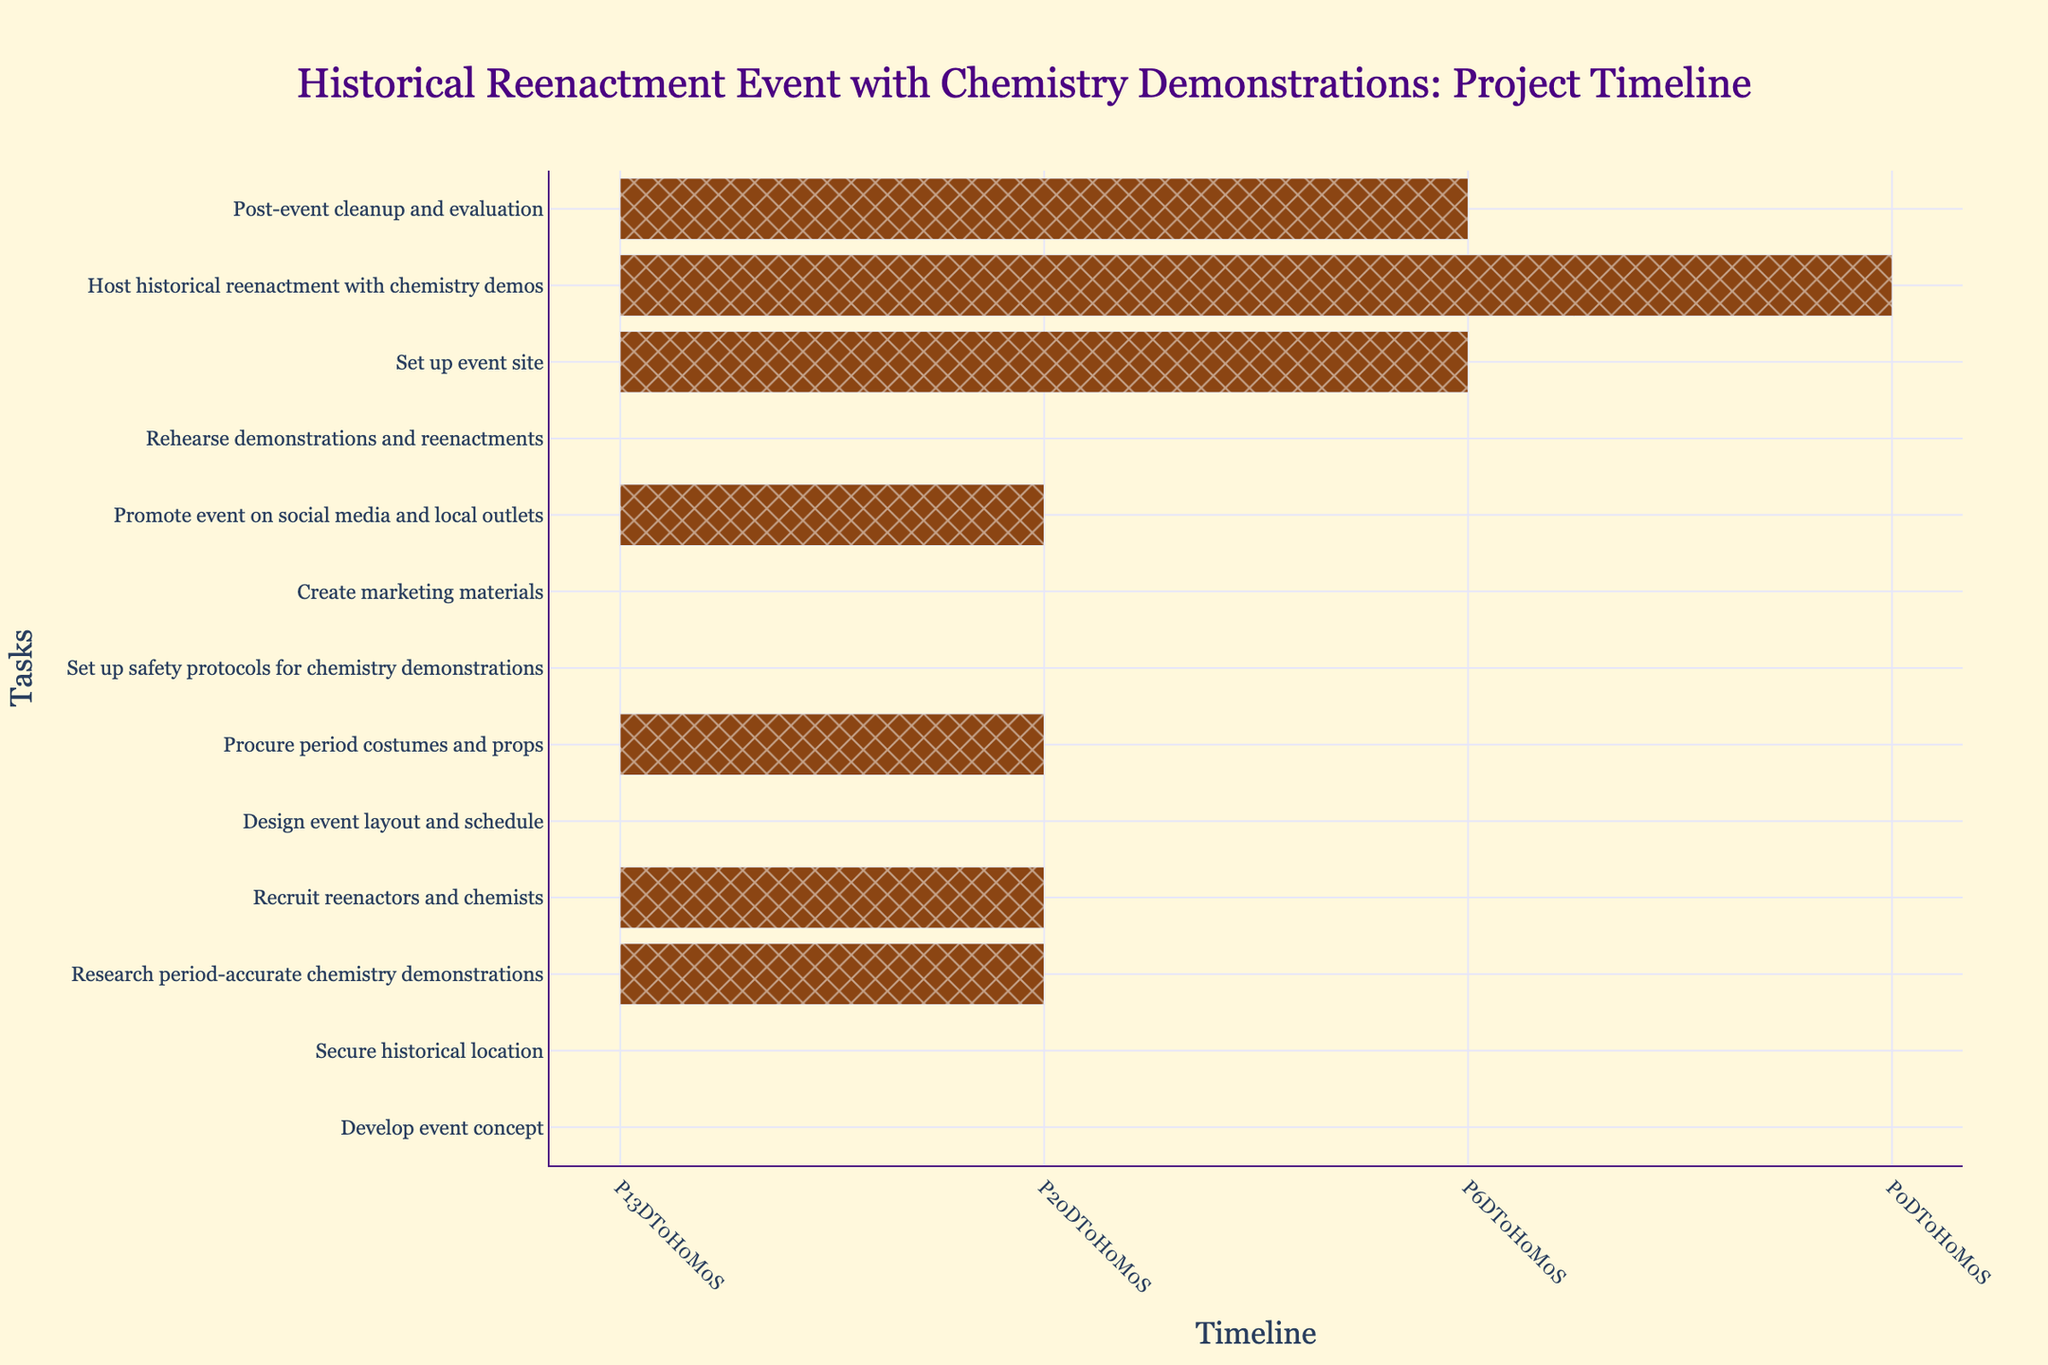Which task starts first? The first task on the timeline starts at the earliest date. Referring to the figure, identify the task with the earliest start date.
Answer: Develop event concept What is the duration of the "Promote event on social media and local outlets" task? Look at this specific task on the Gantt chart and refer to its duration.
Answer: 21 days Which task has the longest duration? Review the duration of each task listed on the Gantt chart and identify the one with the maximum duration.
Answer: Research period-accurate chemistry demonstrations Which two tasks occur concurrently at least partially? Identify tasks that have overlapping date ranges. For example, check the start and end dates of neighboring tasks to find overlaps.
Answer: Create marketing materials and Promote event on social media and local outlets When does the task "Set up event site" start? Locate the "Set up event site" task on the chart and read its start date from the timeline.
Answer: 2023-10-16 How many tasks have a duration of exactly 21 days? Count the tasks on the Gantt chart that are listed with a duration of 21 days.
Answer: 3 What tasks are scheduled between September and October? Examine tasks on the chart scheduled within the time frame from September to October. Identify the tasks starting, ending, or occurring in these months.
Answer: Create marketing materials, Promote event on social media and local outlets, Rehearse demonstrations and reenactments, Set up event site, Host historical reenactment with chemistry demos, Post-event cleanup and evaluation What is the total duration of tasks from the beginning until "Set up safety protocols for chemistry demonstrations"? Sum the duration of each task sequentially from the start date of the project until the end of the mentioned task. Including respective durations of each task: (14 + 14 + 21 + 21 + 14 + 21 + 14).
Answer: 119 days Which task ends last? Identify the task with the latest end date on the Gantt chart timeline.
Answer: Post-event cleanup and evaluation Does any task have a start date in the month of June? Check the start dates of tasks on the Gantt chart to see if any of them start in June.
Answer: Yes, "Recruit reenactors and chemists" starts on June 19 